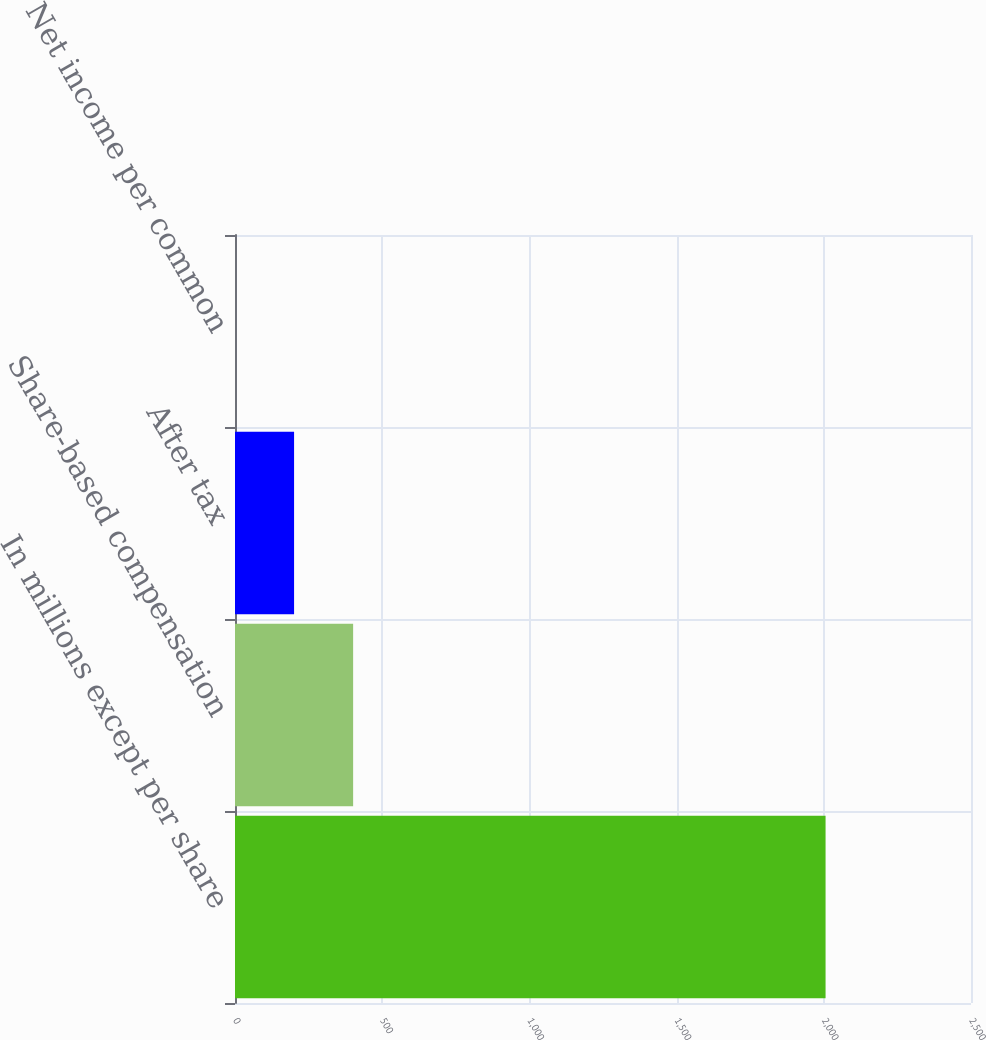<chart> <loc_0><loc_0><loc_500><loc_500><bar_chart><fcel>In millions except per share<fcel>Share-based compensation<fcel>After tax<fcel>Net income per common<nl><fcel>2006<fcel>401.25<fcel>200.66<fcel>0.07<nl></chart> 